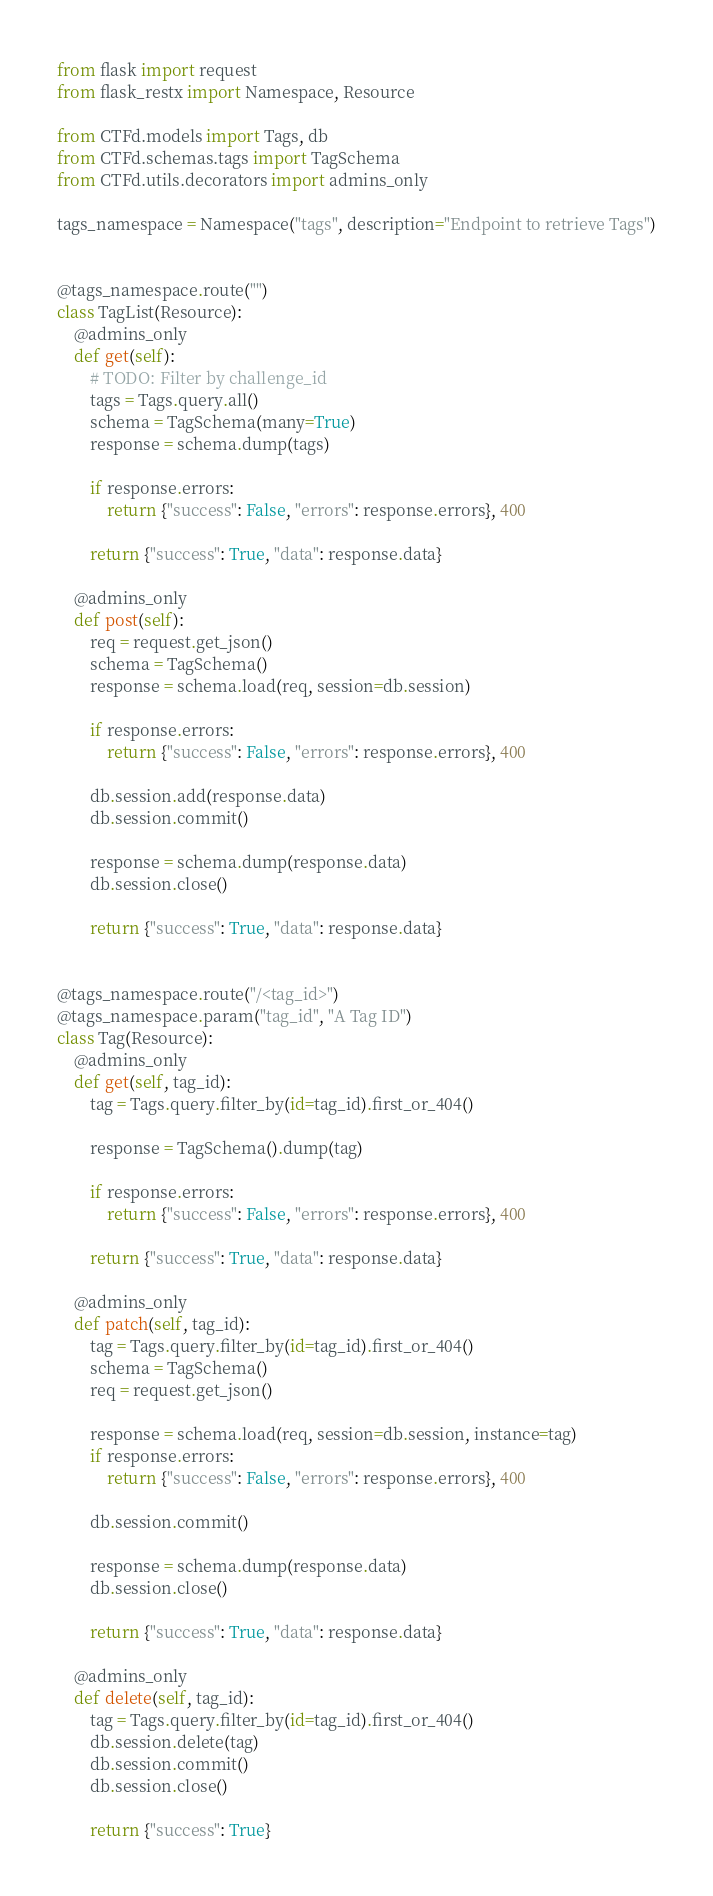<code> <loc_0><loc_0><loc_500><loc_500><_Python_>from flask import request
from flask_restx import Namespace, Resource

from CTFd.models import Tags, db
from CTFd.schemas.tags import TagSchema
from CTFd.utils.decorators import admins_only

tags_namespace = Namespace("tags", description="Endpoint to retrieve Tags")


@tags_namespace.route("")
class TagList(Resource):
    @admins_only
    def get(self):
        # TODO: Filter by challenge_id
        tags = Tags.query.all()
        schema = TagSchema(many=True)
        response = schema.dump(tags)

        if response.errors:
            return {"success": False, "errors": response.errors}, 400

        return {"success": True, "data": response.data}

    @admins_only
    def post(self):
        req = request.get_json()
        schema = TagSchema()
        response = schema.load(req, session=db.session)

        if response.errors:
            return {"success": False, "errors": response.errors}, 400

        db.session.add(response.data)
        db.session.commit()

        response = schema.dump(response.data)
        db.session.close()

        return {"success": True, "data": response.data}


@tags_namespace.route("/<tag_id>")
@tags_namespace.param("tag_id", "A Tag ID")
class Tag(Resource):
    @admins_only
    def get(self, tag_id):
        tag = Tags.query.filter_by(id=tag_id).first_or_404()

        response = TagSchema().dump(tag)

        if response.errors:
            return {"success": False, "errors": response.errors}, 400

        return {"success": True, "data": response.data}

    @admins_only
    def patch(self, tag_id):
        tag = Tags.query.filter_by(id=tag_id).first_or_404()
        schema = TagSchema()
        req = request.get_json()

        response = schema.load(req, session=db.session, instance=tag)
        if response.errors:
            return {"success": False, "errors": response.errors}, 400

        db.session.commit()

        response = schema.dump(response.data)
        db.session.close()

        return {"success": True, "data": response.data}

    @admins_only
    def delete(self, tag_id):
        tag = Tags.query.filter_by(id=tag_id).first_or_404()
        db.session.delete(tag)
        db.session.commit()
        db.session.close()

        return {"success": True}
</code> 